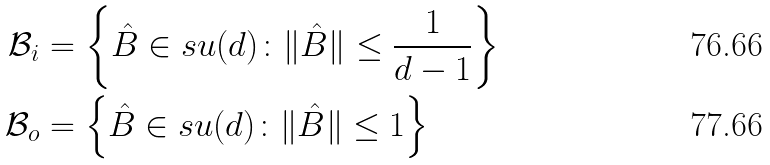Convert formula to latex. <formula><loc_0><loc_0><loc_500><loc_500>\mathcal { B } _ { i } & = \left \{ \hat { B } \in s u ( d ) \colon \| \hat { B } \| \leq \frac { 1 } { d - 1 } \right \} \\ \mathcal { B } _ { o } & = \left \{ \hat { B } \in s u ( d ) \colon \| \hat { B } \| \leq 1 \right \}</formula> 